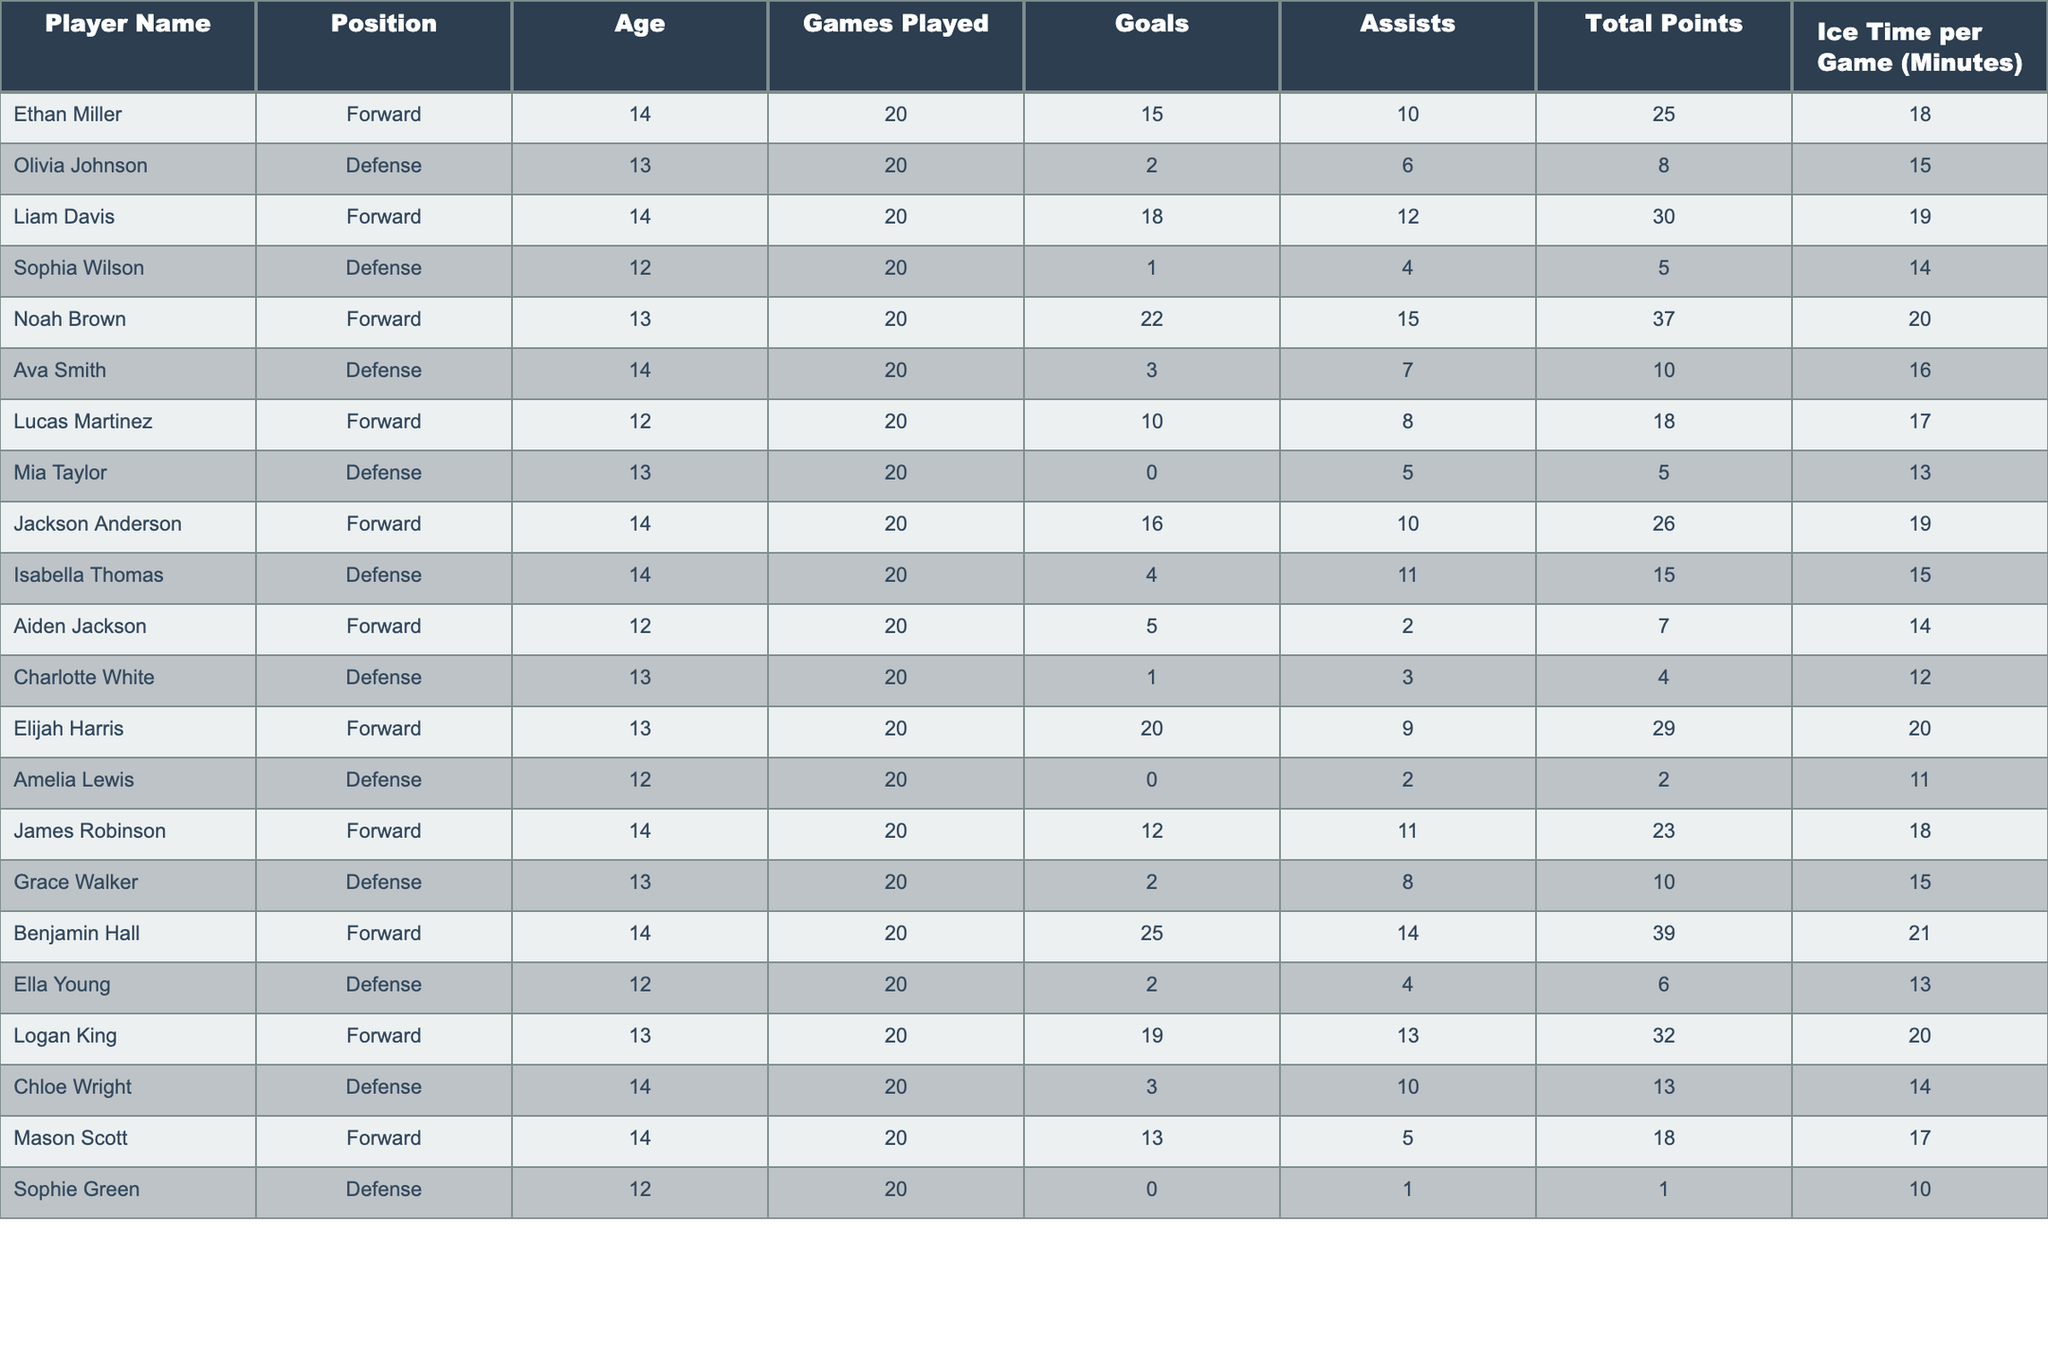What is the total number of goals scored by all players? To find the total number of goals scored, sum the goals column. The goals are: 15 + 2 + 18 + 1 + 22 + 3 + 10 + 0 + 16 + 4 + 5 + 1 + 20 + 0 + 12 + 2 + 25 + 2 + 19 + 3 + 13 + 0 =  168
Answer: 168 Who has the highest total points and what are they? The total points can be found in the total points column. The values are: 25, 8, 30, 5, 37, 10, 18, 5, 26, 15, 7, 4, 29, 2, 23, 10, 39, 6, 32, 13, 18, 1. The highest is 39.
Answer: 39 Which player has the least ice time per game? Review the ice time per game column to find the minimum. The ice times are: 18, 15, 19, 14, 20, 16, 17, 13, 19, 15, 14, 12, 20, 11, 18, 15, 21, 13, 20, 14, 17, 10. The least is 10 minutes.
Answer: 10 minutes What is the average age of all players? To find the average age, sum the ages: 14 + 13 + 14 + 12 + 13 + 14 + 12 + 13 + 14 + 14 + 12 + 13 + 13 + 12 + 14 + 13 + 14 + 12 + 13 + 14 + 14 + 12 = 287. There are 22 players, so the average age is 287 / 22 ≈ 13.05.
Answer: Approximately 13.05 How many forwards scored more than 20 points? Count the forwards in the position column with more than 20 points in the total points column. The forwards with points are: 25 (Benjamin), 22 (Noah), 20 (Elijah), and 18 (Liam). That gives us a total of 4 forwards.
Answer: 4 Is there a player aged 12 who scored more than 5 points? Look at the players aged 12 in the age column and check their total points. The players are Lucas (18 points), Aiden (7 points), and Sophie (1 point). Lucas and Aiden scored above 5 points, so the answer is yes.
Answer: Yes What is the difference between the highest and lowest number of assists among all players? Identify the highest assists: 15 (Olivia) and the lowest: 1 (Sophie). Find the difference: 15 - 1 = 14.
Answer: 14 Which position has the highest average ice time per game? Calculate the average ice time per position. Forwards: (18 + 19 + 20 + 19 + 21 + 20 + 17) / 7 ≈ 19.14, Defence: (15 + 14 + 16 + 15 + 12 + 15 + 13 + 14 + 13 + 10) / 12 ≈ 13.67. Forwards have the highest average.
Answer: Forwards How many players have played all 20 games? Count how many players have "20" in the Games Played column. Since all players have played 20 games, the answer is 22.
Answer: 22 What percentage of players are defense and have at least 10 total points? Count defense players: 11 (Olivia, Sophia, Ava, Isabella, Grace, Chloe) out of 22 total players, only 2 defense players (Olivia, Isabella) scored at least 10 points. The percentage is (2 / 11) * 100 ≈ 18.18%.
Answer: Approximately 18.18% 